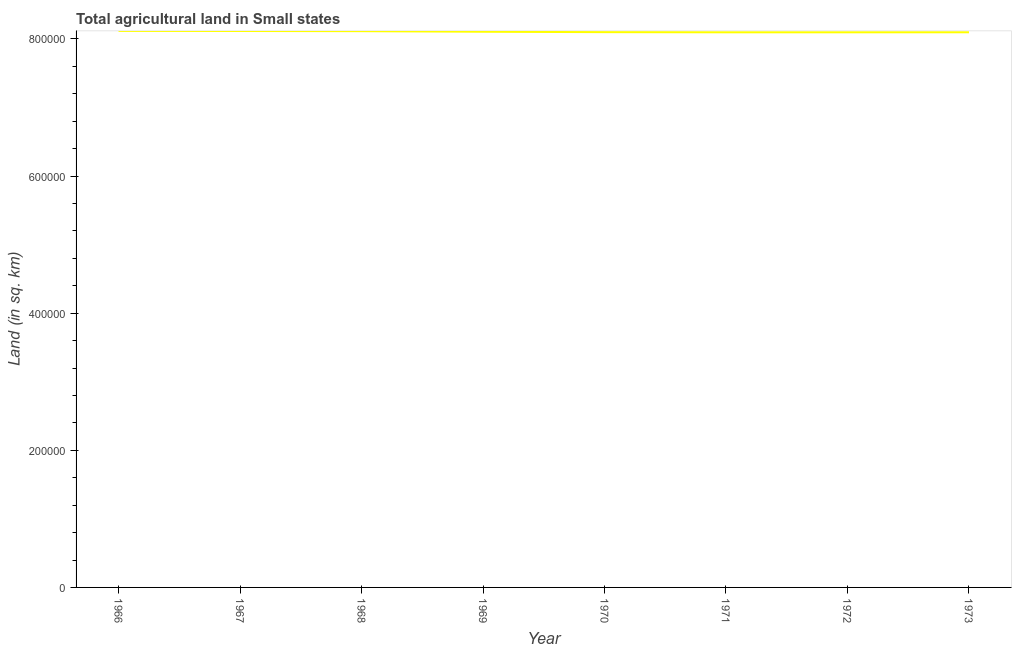What is the agricultural land in 1971?
Your answer should be compact. 8.10e+05. Across all years, what is the maximum agricultural land?
Your answer should be very brief. 8.12e+05. Across all years, what is the minimum agricultural land?
Provide a short and direct response. 8.10e+05. In which year was the agricultural land maximum?
Your response must be concise. 1966. In which year was the agricultural land minimum?
Offer a very short reply. 1972. What is the sum of the agricultural land?
Offer a very short reply. 6.48e+06. What is the difference between the agricultural land in 1969 and 1973?
Keep it short and to the point. 780. What is the average agricultural land per year?
Offer a terse response. 8.11e+05. What is the median agricultural land?
Provide a succinct answer. 8.10e+05. In how many years, is the agricultural land greater than 680000 sq. km?
Give a very brief answer. 8. What is the ratio of the agricultural land in 1969 to that in 1973?
Your answer should be very brief. 1. Is the difference between the agricultural land in 1970 and 1972 greater than the difference between any two years?
Provide a succinct answer. No. What is the difference between the highest and the second highest agricultural land?
Ensure brevity in your answer.  160. What is the difference between the highest and the lowest agricultural land?
Ensure brevity in your answer.  2070. In how many years, is the agricultural land greater than the average agricultural land taken over all years?
Ensure brevity in your answer.  3. How many lines are there?
Provide a succinct answer. 1. What is the difference between two consecutive major ticks on the Y-axis?
Offer a terse response. 2.00e+05. Does the graph contain any zero values?
Keep it short and to the point. No. What is the title of the graph?
Give a very brief answer. Total agricultural land in Small states. What is the label or title of the Y-axis?
Provide a short and direct response. Land (in sq. km). What is the Land (in sq. km) of 1966?
Your answer should be compact. 8.12e+05. What is the Land (in sq. km) of 1967?
Make the answer very short. 8.12e+05. What is the Land (in sq. km) of 1968?
Your answer should be compact. 8.11e+05. What is the Land (in sq. km) in 1969?
Your response must be concise. 8.11e+05. What is the Land (in sq. km) in 1970?
Your answer should be very brief. 8.10e+05. What is the Land (in sq. km) of 1971?
Your answer should be very brief. 8.10e+05. What is the Land (in sq. km) in 1972?
Offer a terse response. 8.10e+05. What is the Land (in sq. km) of 1973?
Provide a succinct answer. 8.10e+05. What is the difference between the Land (in sq. km) in 1966 and 1967?
Ensure brevity in your answer.  160. What is the difference between the Land (in sq. km) in 1966 and 1968?
Offer a terse response. 410. What is the difference between the Land (in sq. km) in 1966 and 1969?
Make the answer very short. 1240. What is the difference between the Land (in sq. km) in 1966 and 1970?
Your answer should be very brief. 1845. What is the difference between the Land (in sq. km) in 1966 and 1971?
Provide a succinct answer. 2060. What is the difference between the Land (in sq. km) in 1966 and 1972?
Provide a succinct answer. 2070. What is the difference between the Land (in sq. km) in 1966 and 1973?
Offer a very short reply. 2020. What is the difference between the Land (in sq. km) in 1967 and 1968?
Your answer should be very brief. 250. What is the difference between the Land (in sq. km) in 1967 and 1969?
Offer a terse response. 1080. What is the difference between the Land (in sq. km) in 1967 and 1970?
Give a very brief answer. 1685. What is the difference between the Land (in sq. km) in 1967 and 1971?
Provide a short and direct response. 1900. What is the difference between the Land (in sq. km) in 1967 and 1972?
Make the answer very short. 1910. What is the difference between the Land (in sq. km) in 1967 and 1973?
Keep it short and to the point. 1860. What is the difference between the Land (in sq. km) in 1968 and 1969?
Make the answer very short. 830. What is the difference between the Land (in sq. km) in 1968 and 1970?
Ensure brevity in your answer.  1435. What is the difference between the Land (in sq. km) in 1968 and 1971?
Your answer should be compact. 1650. What is the difference between the Land (in sq. km) in 1968 and 1972?
Offer a very short reply. 1660. What is the difference between the Land (in sq. km) in 1968 and 1973?
Your response must be concise. 1610. What is the difference between the Land (in sq. km) in 1969 and 1970?
Provide a short and direct response. 605. What is the difference between the Land (in sq. km) in 1969 and 1971?
Offer a very short reply. 820. What is the difference between the Land (in sq. km) in 1969 and 1972?
Your response must be concise. 830. What is the difference between the Land (in sq. km) in 1969 and 1973?
Keep it short and to the point. 780. What is the difference between the Land (in sq. km) in 1970 and 1971?
Provide a succinct answer. 215. What is the difference between the Land (in sq. km) in 1970 and 1972?
Make the answer very short. 225. What is the difference between the Land (in sq. km) in 1970 and 1973?
Offer a very short reply. 175. What is the difference between the Land (in sq. km) in 1971 and 1972?
Keep it short and to the point. 10. What is the ratio of the Land (in sq. km) in 1966 to that in 1969?
Offer a terse response. 1. What is the ratio of the Land (in sq. km) in 1966 to that in 1970?
Your response must be concise. 1. What is the ratio of the Land (in sq. km) in 1966 to that in 1972?
Offer a terse response. 1. What is the ratio of the Land (in sq. km) in 1966 to that in 1973?
Give a very brief answer. 1. What is the ratio of the Land (in sq. km) in 1967 to that in 1968?
Give a very brief answer. 1. What is the ratio of the Land (in sq. km) in 1967 to that in 1970?
Offer a terse response. 1. What is the ratio of the Land (in sq. km) in 1967 to that in 1972?
Give a very brief answer. 1. What is the ratio of the Land (in sq. km) in 1967 to that in 1973?
Your answer should be compact. 1. What is the ratio of the Land (in sq. km) in 1968 to that in 1969?
Your answer should be compact. 1. What is the ratio of the Land (in sq. km) in 1968 to that in 1970?
Your answer should be compact. 1. What is the ratio of the Land (in sq. km) in 1968 to that in 1971?
Your answer should be compact. 1. What is the ratio of the Land (in sq. km) in 1968 to that in 1972?
Your response must be concise. 1. What is the ratio of the Land (in sq. km) in 1968 to that in 1973?
Your response must be concise. 1. What is the ratio of the Land (in sq. km) in 1969 to that in 1970?
Offer a terse response. 1. What is the ratio of the Land (in sq. km) in 1969 to that in 1973?
Your answer should be compact. 1. What is the ratio of the Land (in sq. km) in 1970 to that in 1971?
Keep it short and to the point. 1. What is the ratio of the Land (in sq. km) in 1970 to that in 1972?
Your answer should be compact. 1. What is the ratio of the Land (in sq. km) in 1970 to that in 1973?
Your response must be concise. 1. What is the ratio of the Land (in sq. km) in 1971 to that in 1972?
Offer a very short reply. 1. What is the ratio of the Land (in sq. km) in 1971 to that in 1973?
Offer a very short reply. 1. What is the ratio of the Land (in sq. km) in 1972 to that in 1973?
Make the answer very short. 1. 